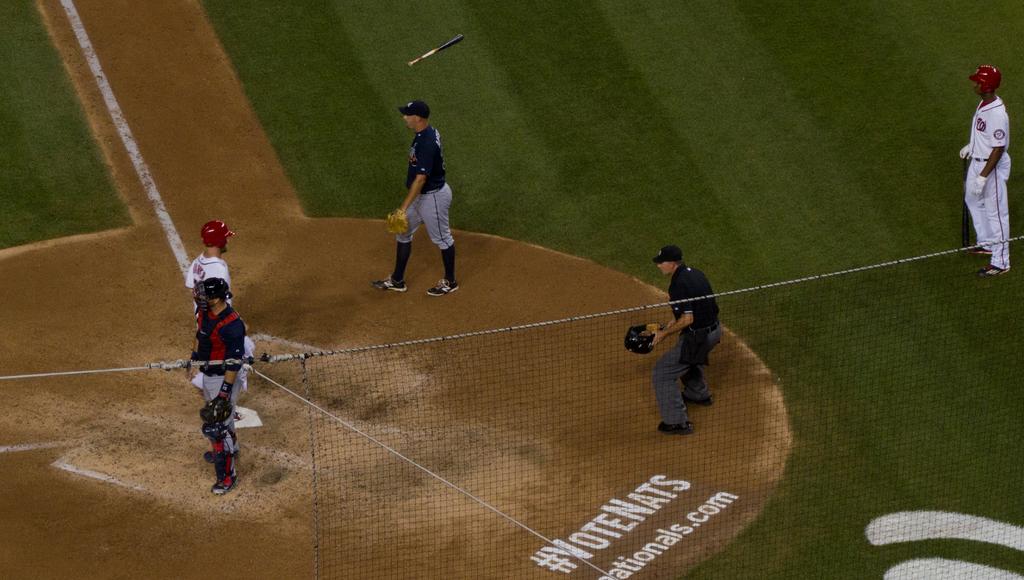What hashtag is on the field?
Offer a very short reply. Votenats. What website is displayed?
Provide a short and direct response. Nationals.com. 